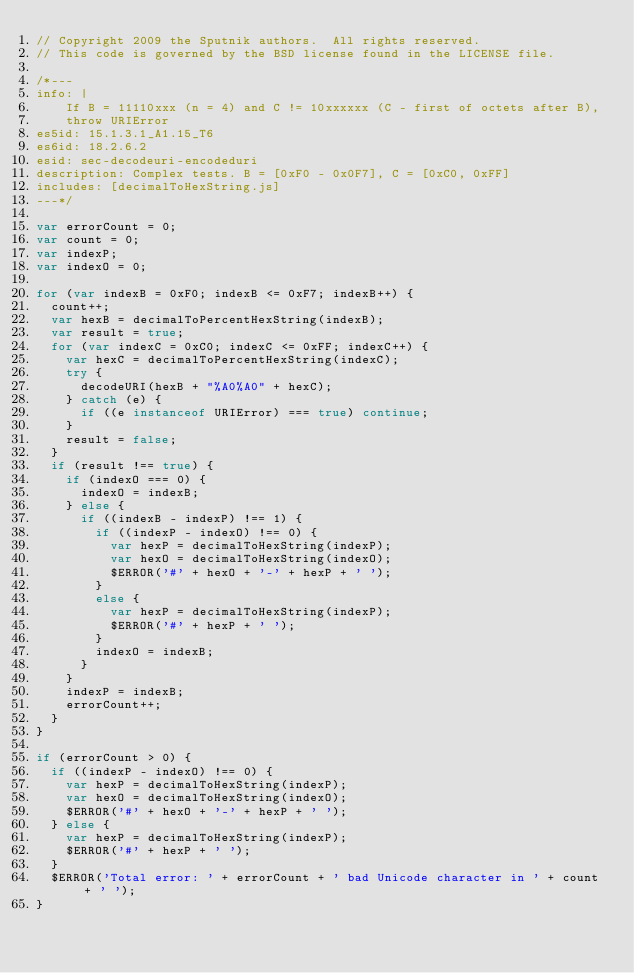Convert code to text. <code><loc_0><loc_0><loc_500><loc_500><_JavaScript_>// Copyright 2009 the Sputnik authors.  All rights reserved.
// This code is governed by the BSD license found in the LICENSE file.

/*---
info: |
    If B = 11110xxx (n = 4) and C != 10xxxxxx (C - first of octets after B),
    throw URIError
es5id: 15.1.3.1_A1.15_T6
es6id: 18.2.6.2
esid: sec-decodeuri-encodeduri
description: Complex tests. B = [0xF0 - 0x0F7], C = [0xC0, 0xFF]
includes: [decimalToHexString.js]
---*/

var errorCount = 0;
var count = 0;
var indexP;
var indexO = 0;

for (var indexB = 0xF0; indexB <= 0xF7; indexB++) {
  count++;
  var hexB = decimalToPercentHexString(indexB);
  var result = true;
  for (var indexC = 0xC0; indexC <= 0xFF; indexC++) {
    var hexC = decimalToPercentHexString(indexC);
    try {
      decodeURI(hexB + "%A0%A0" + hexC);
    } catch (e) {
      if ((e instanceof URIError) === true) continue;
    }
    result = false;
  }
  if (result !== true) {
    if (indexO === 0) {
      indexO = indexB;
    } else {
      if ((indexB - indexP) !== 1) {
        if ((indexP - indexO) !== 0) {
          var hexP = decimalToHexString(indexP);
          var hexO = decimalToHexString(indexO);
          $ERROR('#' + hexO + '-' + hexP + ' ');
        }
        else {
          var hexP = decimalToHexString(indexP);
          $ERROR('#' + hexP + ' ');
        }
        indexO = indexB;
      }
    }
    indexP = indexB;
    errorCount++;
  }
}

if (errorCount > 0) {
  if ((indexP - indexO) !== 0) {
    var hexP = decimalToHexString(indexP);
    var hexO = decimalToHexString(indexO);
    $ERROR('#' + hexO + '-' + hexP + ' ');
  } else {
    var hexP = decimalToHexString(indexP);
    $ERROR('#' + hexP + ' ');
  }
  $ERROR('Total error: ' + errorCount + ' bad Unicode character in ' + count + ' ');
}
</code> 